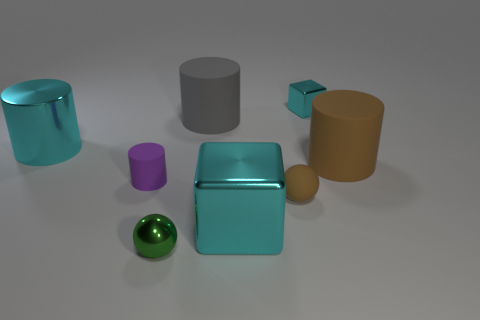Subtract 1 cylinders. How many cylinders are left? 3 Add 2 large rubber cylinders. How many objects exist? 10 Subtract all spheres. How many objects are left? 6 Subtract all big gray matte things. Subtract all metal spheres. How many objects are left? 6 Add 1 small rubber cylinders. How many small rubber cylinders are left? 2 Add 1 tiny yellow metallic cylinders. How many tiny yellow metallic cylinders exist? 1 Subtract 1 purple cylinders. How many objects are left? 7 